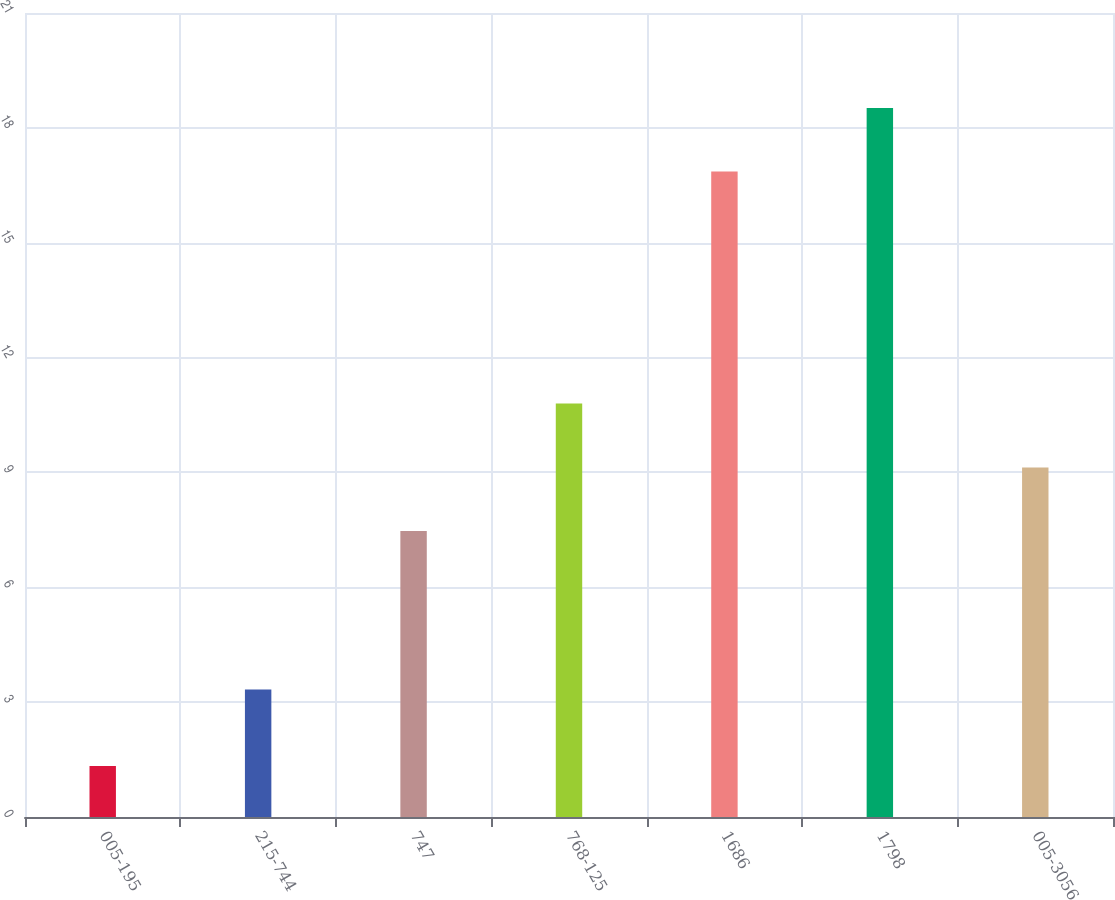<chart> <loc_0><loc_0><loc_500><loc_500><bar_chart><fcel>005-195<fcel>215-744<fcel>747<fcel>768-125<fcel>1686<fcel>1798<fcel>005-3056<nl><fcel>1.33<fcel>3.33<fcel>7.47<fcel>10.8<fcel>16.86<fcel>18.52<fcel>9.13<nl></chart> 